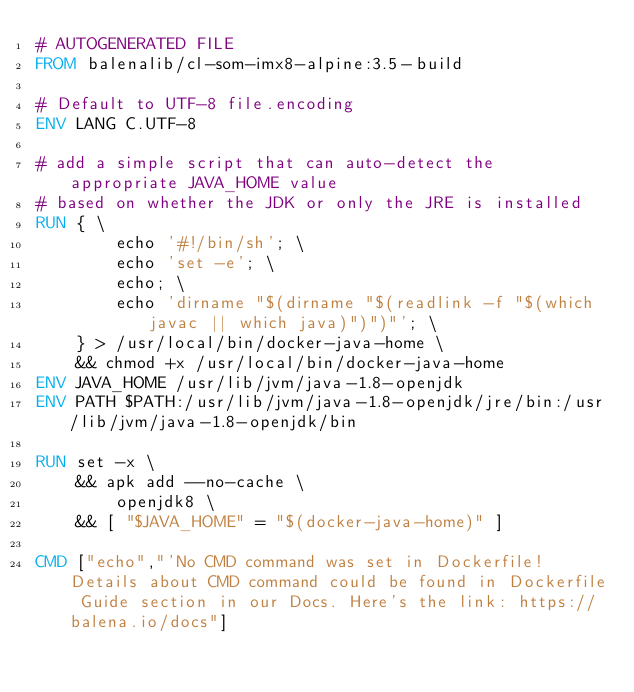Convert code to text. <code><loc_0><loc_0><loc_500><loc_500><_Dockerfile_># AUTOGENERATED FILE
FROM balenalib/cl-som-imx8-alpine:3.5-build

# Default to UTF-8 file.encoding
ENV LANG C.UTF-8

# add a simple script that can auto-detect the appropriate JAVA_HOME value
# based on whether the JDK or only the JRE is installed
RUN { \
		echo '#!/bin/sh'; \
		echo 'set -e'; \
		echo; \
		echo 'dirname "$(dirname "$(readlink -f "$(which javac || which java)")")"'; \
	} > /usr/local/bin/docker-java-home \
	&& chmod +x /usr/local/bin/docker-java-home
ENV JAVA_HOME /usr/lib/jvm/java-1.8-openjdk
ENV PATH $PATH:/usr/lib/jvm/java-1.8-openjdk/jre/bin:/usr/lib/jvm/java-1.8-openjdk/bin

RUN set -x \
	&& apk add --no-cache \
		openjdk8 \
	&& [ "$JAVA_HOME" = "$(docker-java-home)" ]

CMD ["echo","'No CMD command was set in Dockerfile! Details about CMD command could be found in Dockerfile Guide section in our Docs. Here's the link: https://balena.io/docs"]</code> 